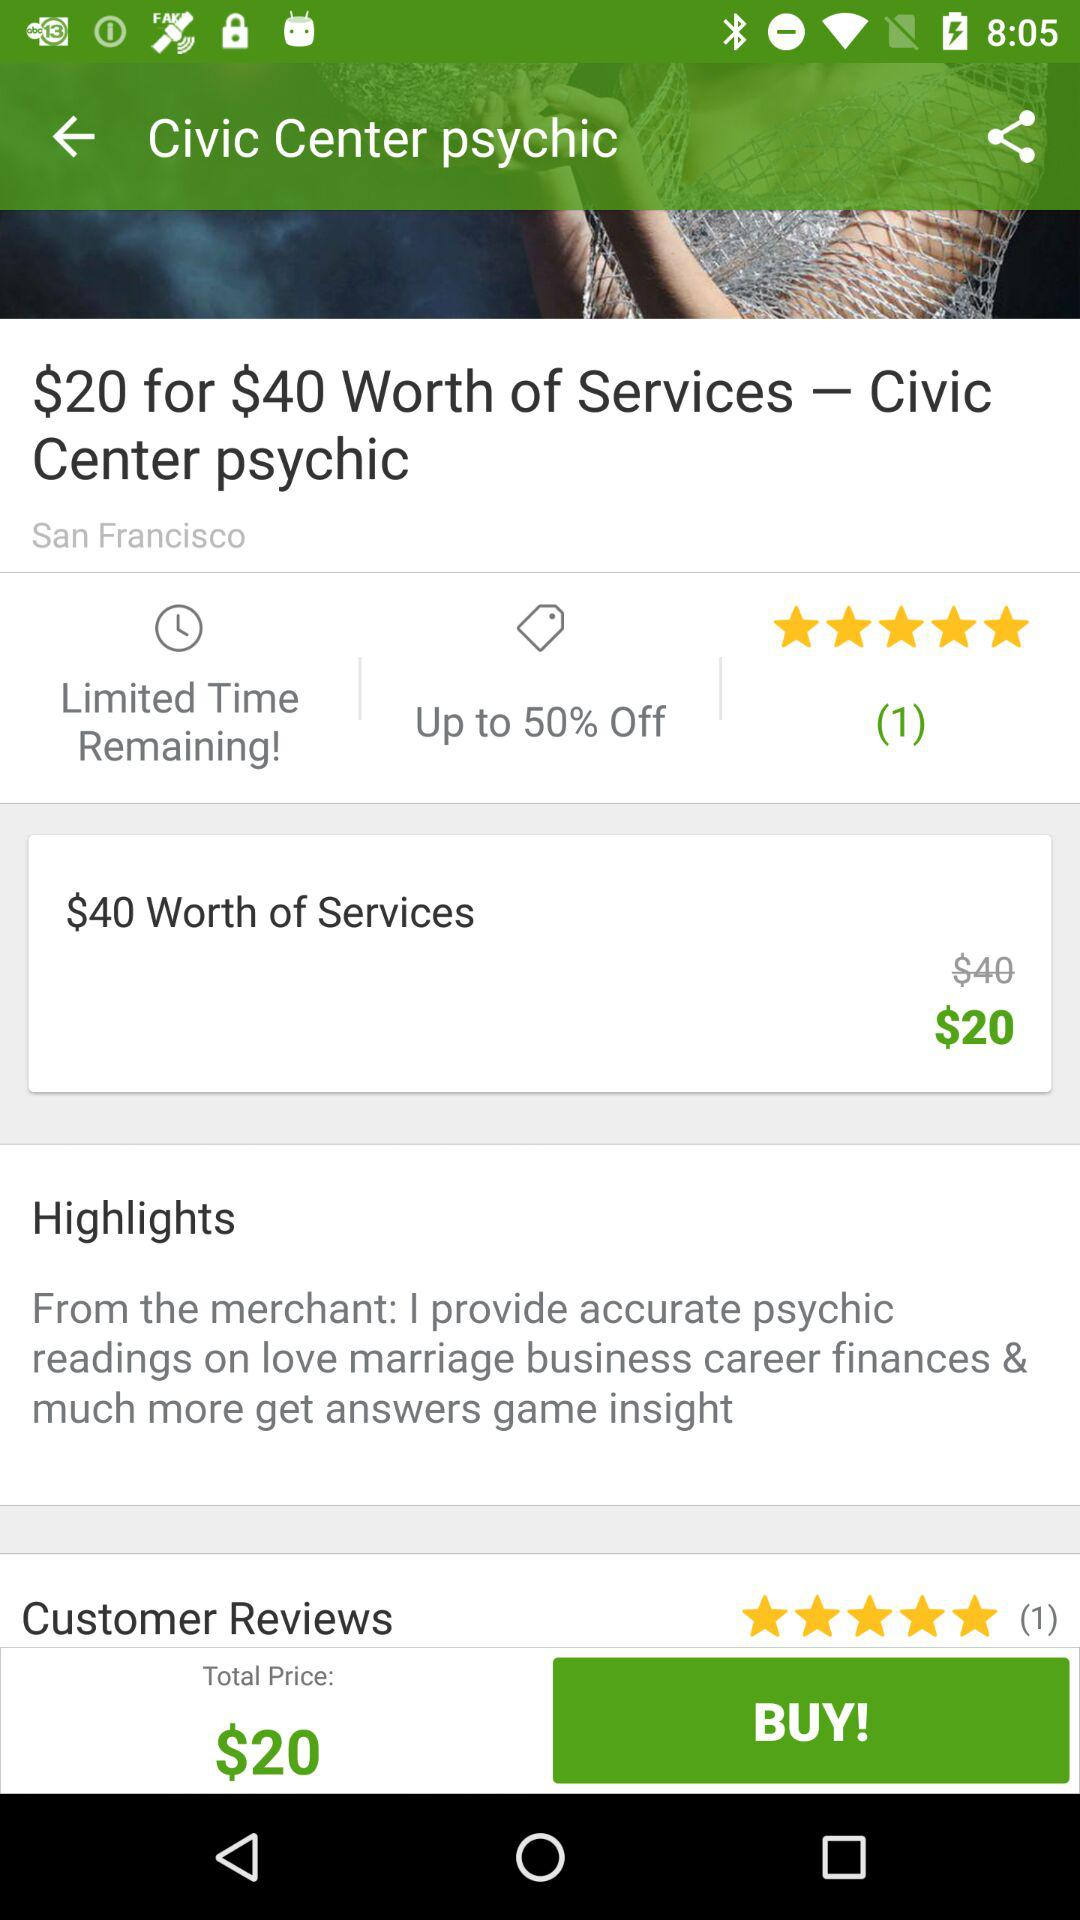Where is the Civic Center psychic located? The Civic Center psychic is located in San Francisco. 